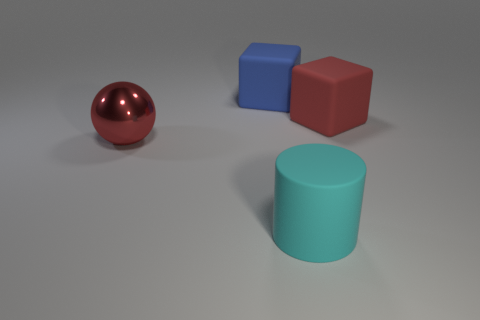What is the shape of the red object to the right of the rubber thing in front of the big metal sphere?
Give a very brief answer. Cube. What number of other things are there of the same color as the rubber cylinder?
Your response must be concise. 0. Does the red object that is on the right side of the blue matte object have the same material as the red object that is left of the blue thing?
Provide a short and direct response. No. There is a red thing behind the red metal ball; what size is it?
Keep it short and to the point. Large. There is a big red object that is the same shape as the large blue matte thing; what material is it?
Your response must be concise. Rubber. Are there any other things that have the same size as the red cube?
Keep it short and to the point. Yes. There is a red object that is left of the blue matte object; what is its shape?
Your response must be concise. Sphere. How many large purple shiny things are the same shape as the big blue object?
Provide a short and direct response. 0. Is the number of red objects left of the large cyan matte object the same as the number of cyan matte cylinders behind the red metallic thing?
Your answer should be very brief. No. Is there a big object made of the same material as the large red sphere?
Keep it short and to the point. No. 